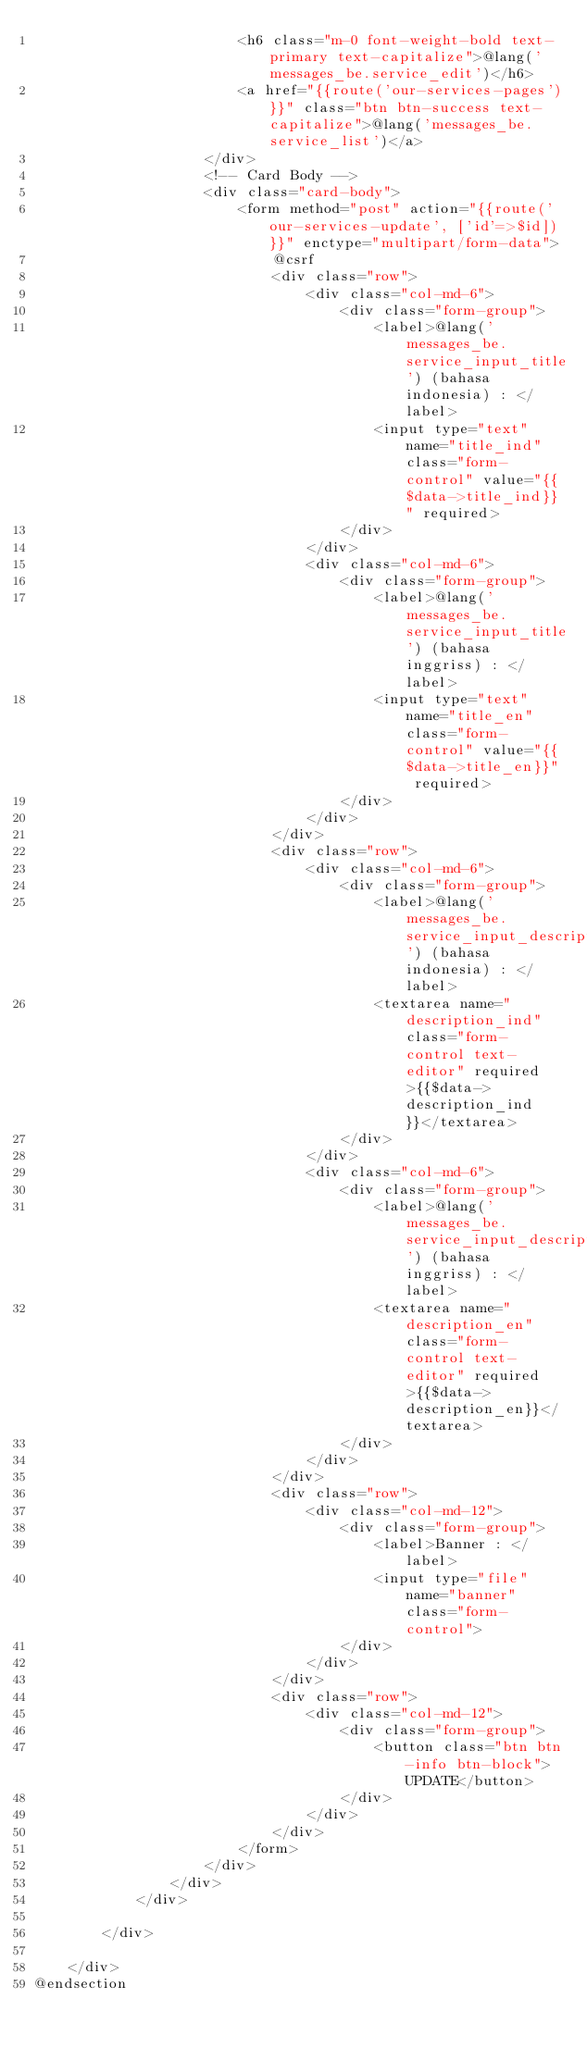Convert code to text. <code><loc_0><loc_0><loc_500><loc_500><_PHP_>                        <h6 class="m-0 font-weight-bold text-primary text-capitalize">@lang('messages_be.service_edit')</h6>
                        <a href="{{route('our-services-pages')}}" class="btn btn-success text-capitalize">@lang('messages_be.service_list')</a>
                    </div>
                    <!-- Card Body -->
                    <div class="card-body">
                        <form method="post" action="{{route('our-services-update', ['id'=>$id])}}" enctype="multipart/form-data">
                            @csrf
                            <div class="row">
                                <div class="col-md-6">
                                    <div class="form-group">
                                        <label>@lang('messages_be.service_input_title') (bahasa indonesia) : </label>
                                        <input type="text" name="title_ind" class="form-control" value="{{$data->title_ind}}" required>
                                    </div>
                                </div>
                                <div class="col-md-6">
                                    <div class="form-group">
                                        <label>@lang('messages_be.service_input_title') (bahasa inggriss) : </label>
                                        <input type="text" name="title_en" class="form-control" value="{{$data->title_en}}" required>
                                    </div>
                                </div>
                            </div>
                            <div class="row">
                                <div class="col-md-6">
                                    <div class="form-group">
                                        <label>@lang('messages_be.service_input_description') (bahasa indonesia) : </label>
                                        <textarea name="description_ind" class="form-control text-editor" required>{{$data->description_ind}}</textarea>
                                    </div>
                                </div>
                                <div class="col-md-6">
                                    <div class="form-group">
                                        <label>@lang('messages_be.service_input_description') (bahasa inggriss) : </label>
                                        <textarea name="description_en" class="form-control text-editor" required>{{$data->description_en}}</textarea>
                                    </div>
                                </div>
                            </div>
                            <div class="row">
                                <div class="col-md-12">
                                    <div class="form-group">
                                        <label>Banner : </label>
                                        <input type="file" name="banner" class="form-control">
                                    </div>
                                </div>
                            </div>
                            <div class="row">
                                <div class="col-md-12">
                                    <div class="form-group">
                                        <button class="btn btn-info btn-block">UPDATE</button>
                                    </div>
                                </div>
                            </div>
                        </form>
                    </div>
                </div>
            </div>

        </div>

    </div>
@endsection</code> 